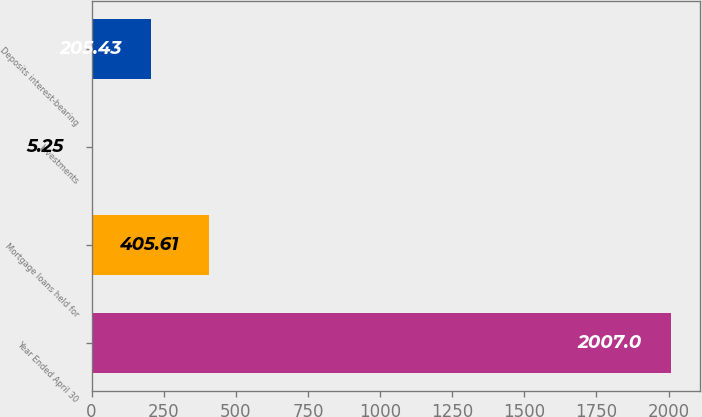Convert chart. <chart><loc_0><loc_0><loc_500><loc_500><bar_chart><fcel>Year Ended April 30<fcel>Mortgage loans held for<fcel>Investments<fcel>Deposits interest-bearing<nl><fcel>2007<fcel>405.61<fcel>5.25<fcel>205.43<nl></chart> 